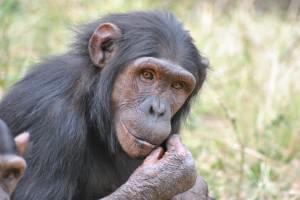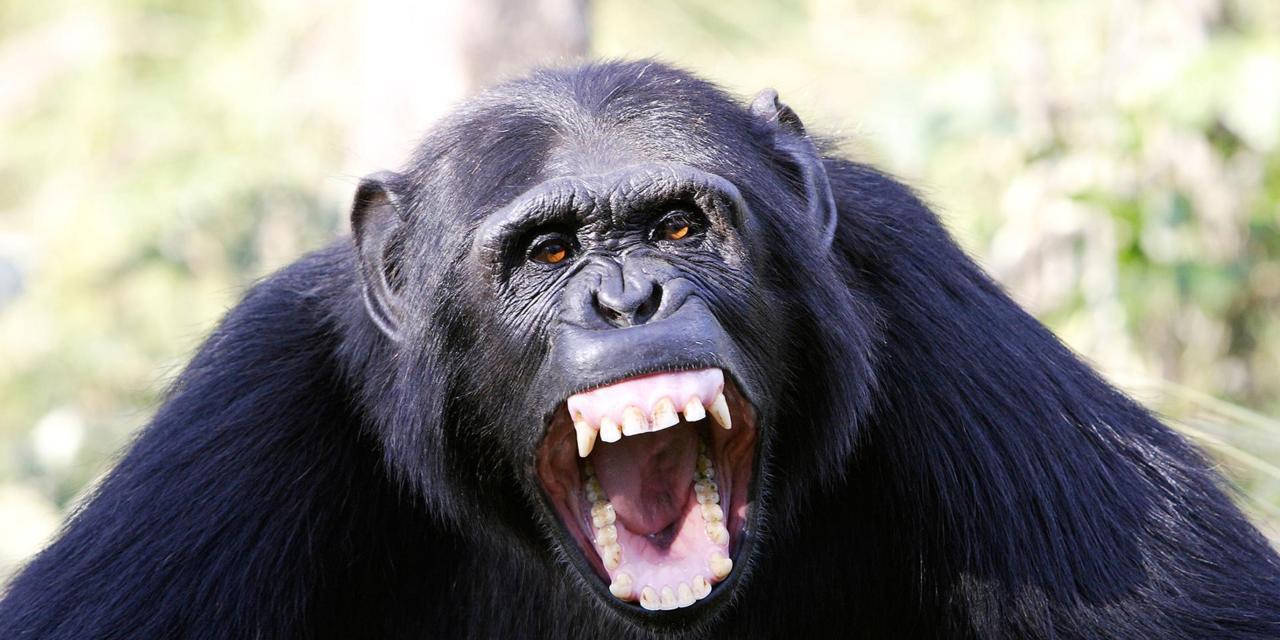The first image is the image on the left, the second image is the image on the right. Given the left and right images, does the statement "An image shows one or more young chimps with hand raised at least at head level." hold true? Answer yes or no. No. 